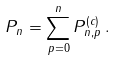<formula> <loc_0><loc_0><loc_500><loc_500>P _ { n } = \sum _ { p = 0 } ^ { n } { P } ^ { ( c ) } _ { n , p } \, .</formula> 